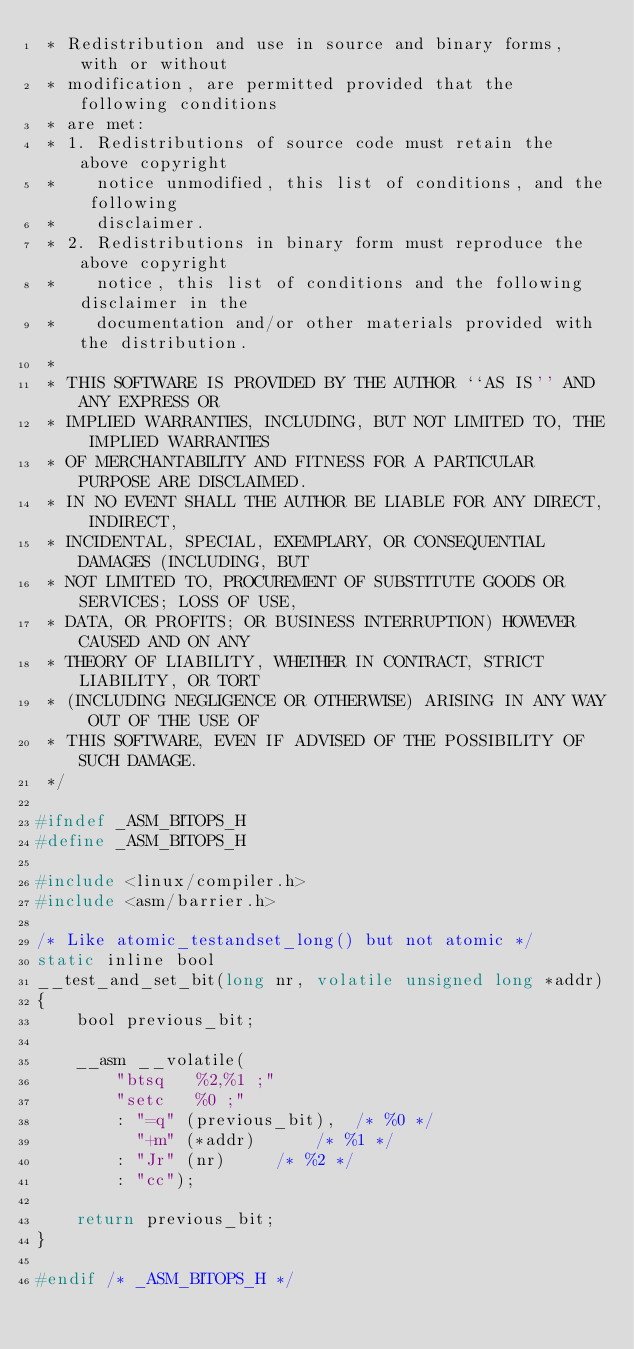Convert code to text. <code><loc_0><loc_0><loc_500><loc_500><_C_> * Redistribution and use in source and binary forms, with or without
 * modification, are permitted provided that the following conditions
 * are met:
 * 1. Redistributions of source code must retain the above copyright
 *    notice unmodified, this list of conditions, and the following
 *    disclaimer.
 * 2. Redistributions in binary form must reproduce the above copyright
 *    notice, this list of conditions and the following disclaimer in the
 *    documentation and/or other materials provided with the distribution.
 *
 * THIS SOFTWARE IS PROVIDED BY THE AUTHOR ``AS IS'' AND ANY EXPRESS OR
 * IMPLIED WARRANTIES, INCLUDING, BUT NOT LIMITED TO, THE IMPLIED WARRANTIES
 * OF MERCHANTABILITY AND FITNESS FOR A PARTICULAR PURPOSE ARE DISCLAIMED.
 * IN NO EVENT SHALL THE AUTHOR BE LIABLE FOR ANY DIRECT, INDIRECT,
 * INCIDENTAL, SPECIAL, EXEMPLARY, OR CONSEQUENTIAL DAMAGES (INCLUDING, BUT
 * NOT LIMITED TO, PROCUREMENT OF SUBSTITUTE GOODS OR SERVICES; LOSS OF USE,
 * DATA, OR PROFITS; OR BUSINESS INTERRUPTION) HOWEVER CAUSED AND ON ANY
 * THEORY OF LIABILITY, WHETHER IN CONTRACT, STRICT LIABILITY, OR TORT
 * (INCLUDING NEGLIGENCE OR OTHERWISE) ARISING IN ANY WAY OUT OF THE USE OF
 * THIS SOFTWARE, EVEN IF ADVISED OF THE POSSIBILITY OF SUCH DAMAGE.
 */

#ifndef _ASM_BITOPS_H
#define _ASM_BITOPS_H

#include <linux/compiler.h>
#include <asm/barrier.h>

/* Like atomic_testandset_long() but not atomic */
static inline bool
__test_and_set_bit(long nr, volatile unsigned long *addr)
{
	bool previous_bit;

	__asm __volatile(
		"btsq	%2,%1 ;"
		"setc	%0 ;"
		: "=q" (previous_bit),	/* %0 */
		  "+m" (*addr)		/* %1 */
		: "Jr" (nr)		/* %2 */
		: "cc");

	return previous_bit;
}

#endif /* _ASM_BITOPS_H */
</code> 